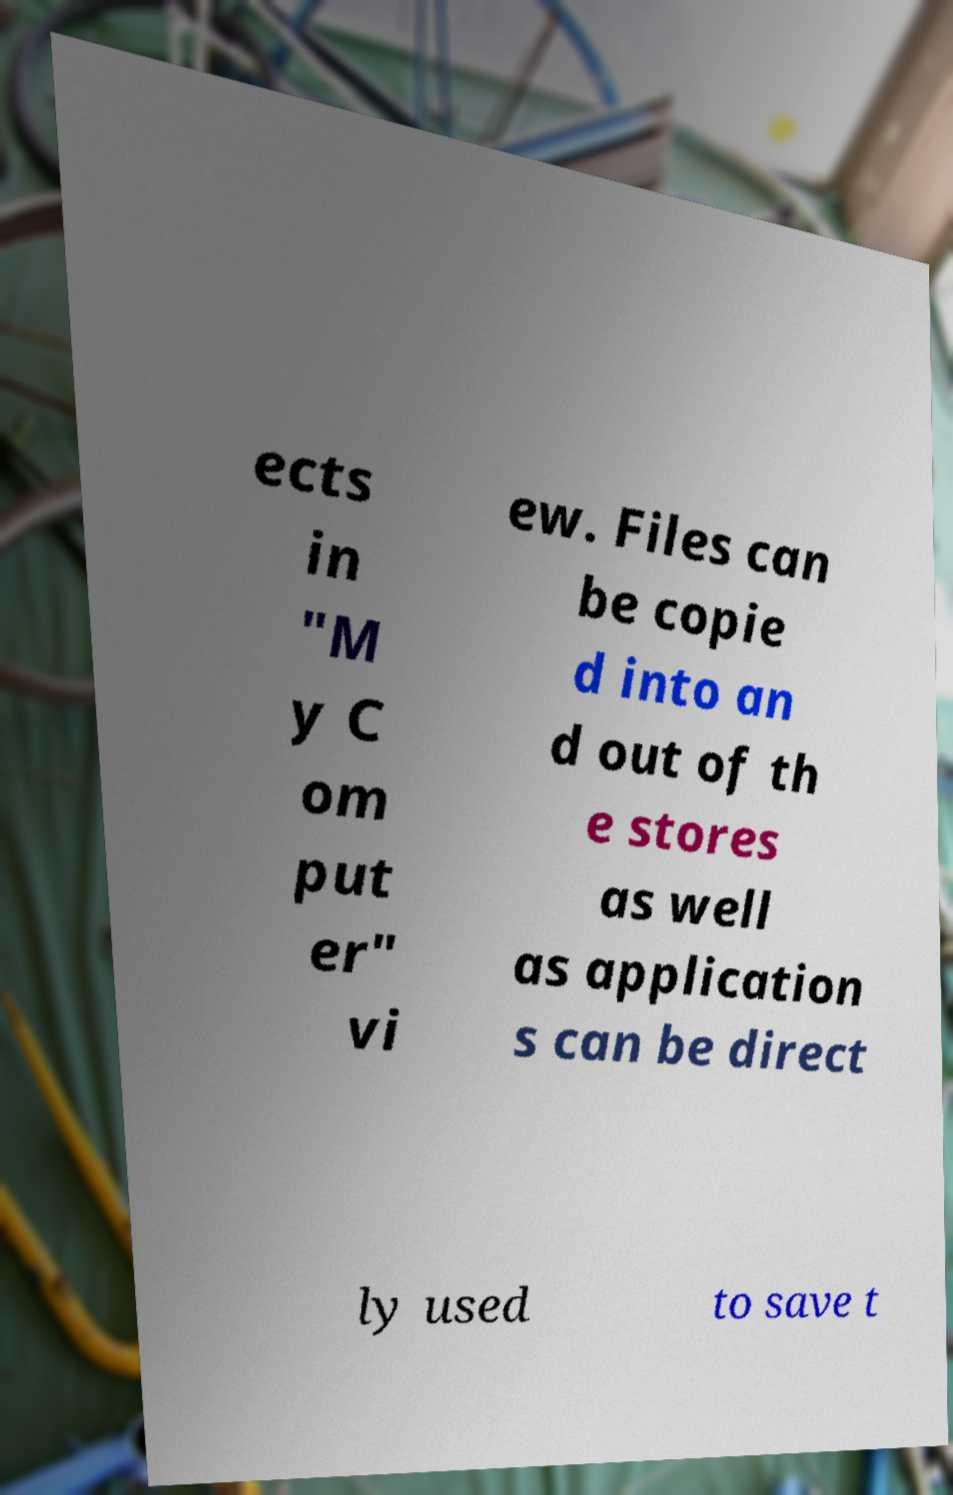Can you accurately transcribe the text from the provided image for me? ects in "M y C om put er" vi ew. Files can be copie d into an d out of th e stores as well as application s can be direct ly used to save t 